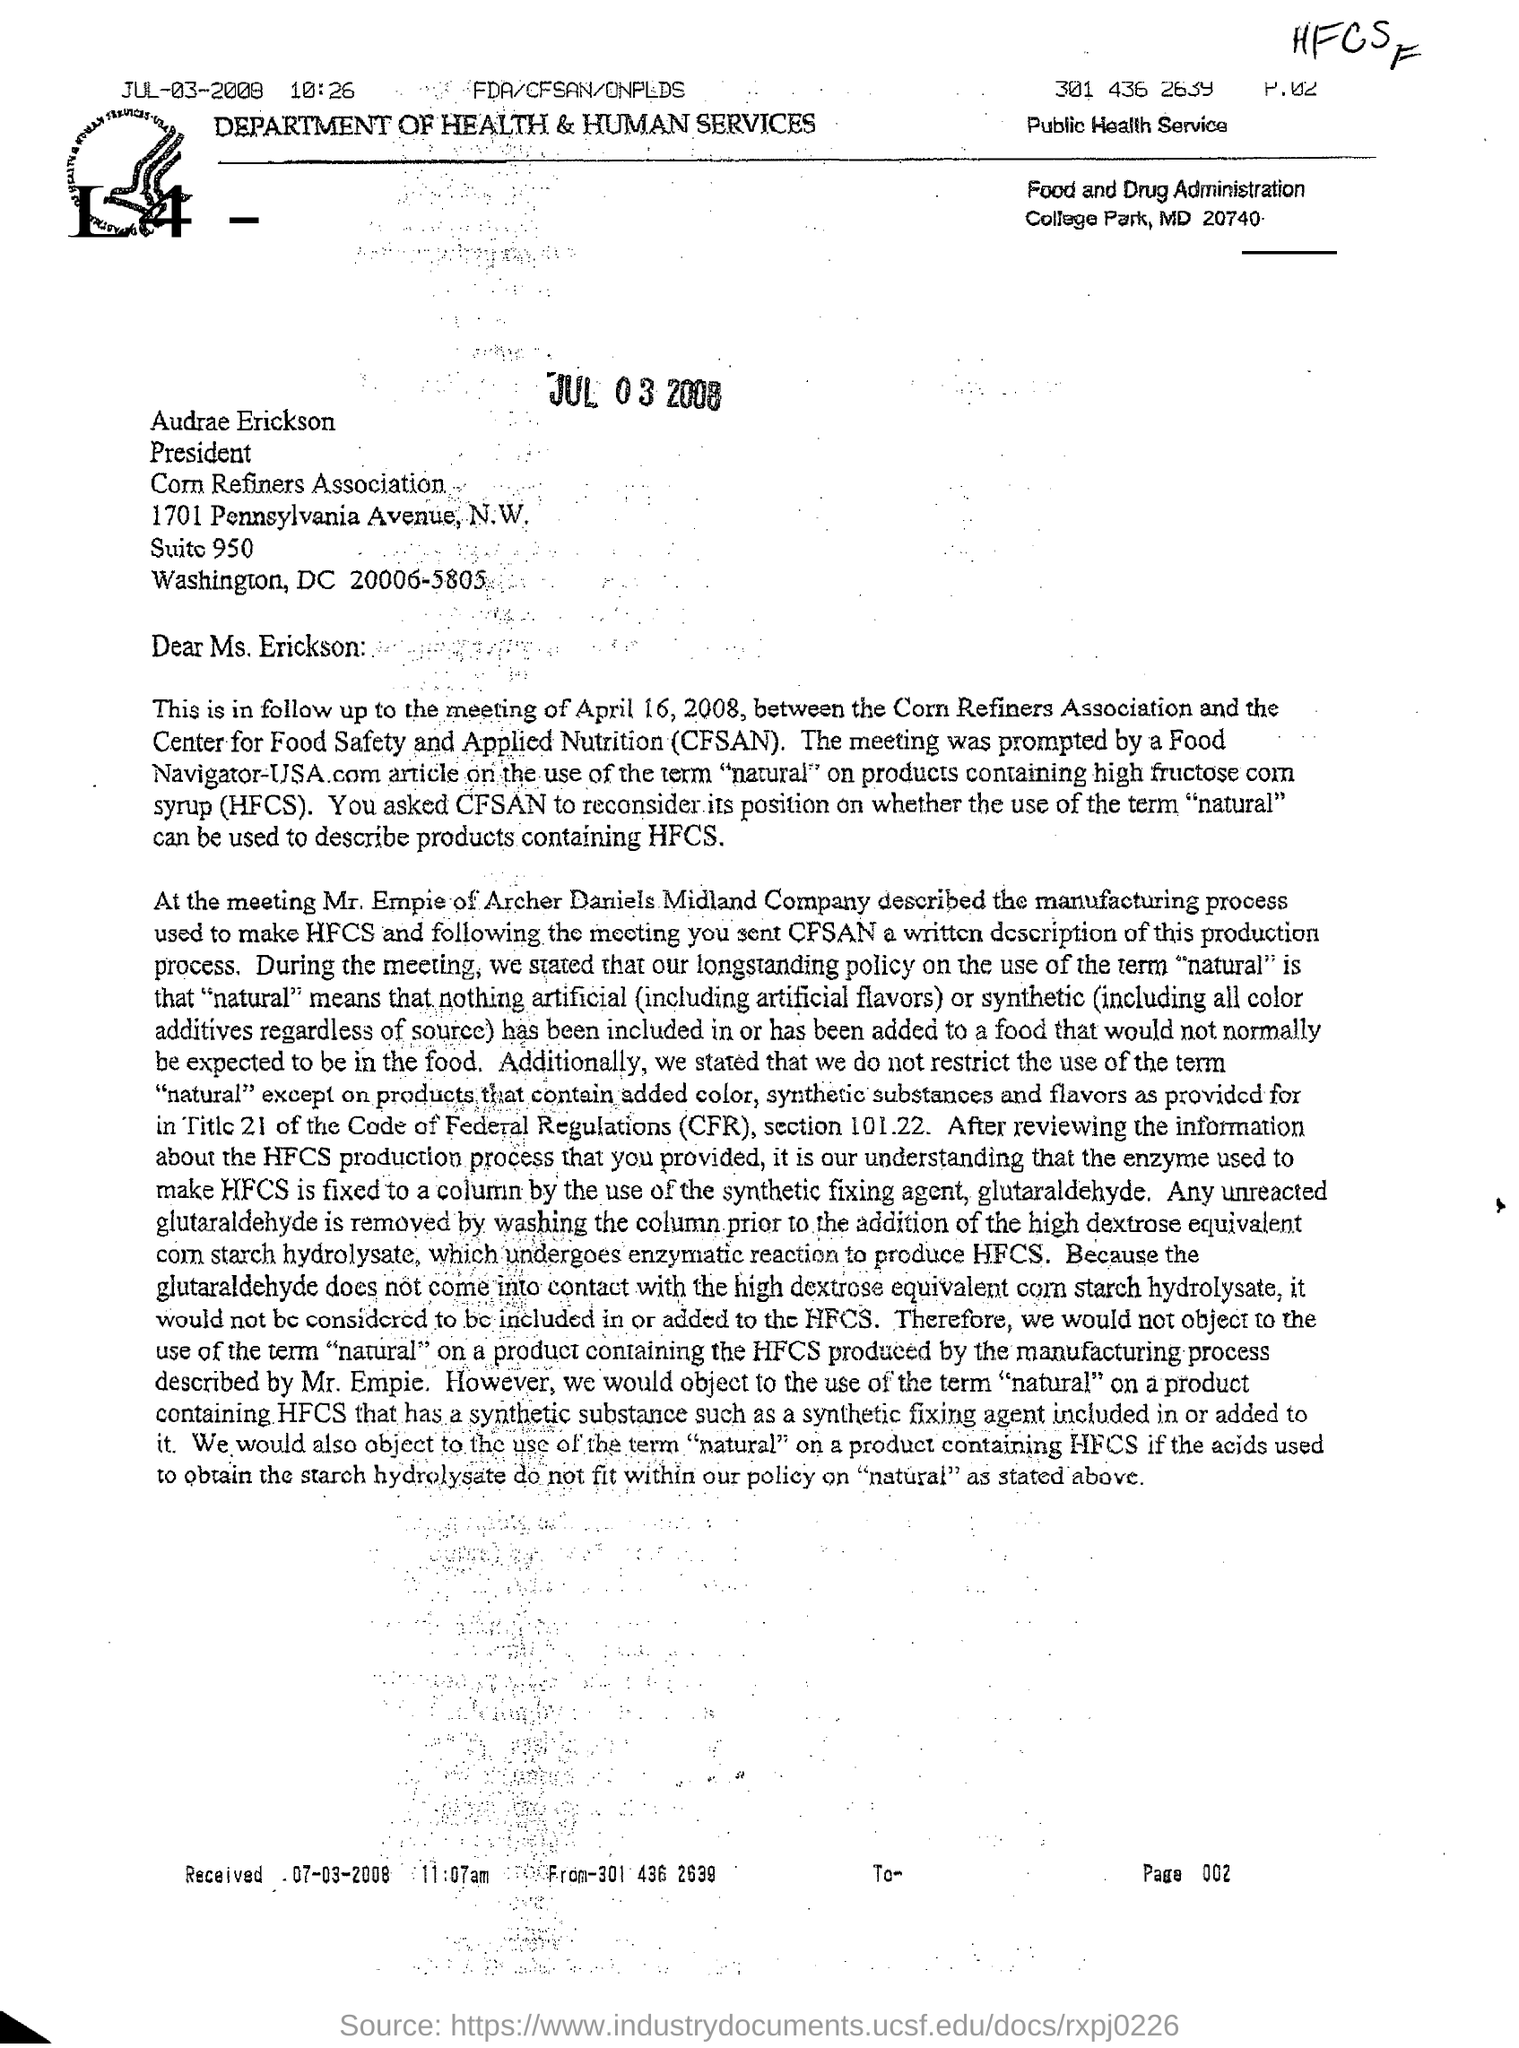Draw attention to some important aspects in this diagram. The letter head mentions the DEPARTMENT OF HEALTH & HUMAN SERVICES. This letter was received on March 7, 2008. The President of the Corn Refiners Association is Audrae Erickson. The full form of CFSAN is the Center for Food Safety and Applied Nutrition. 